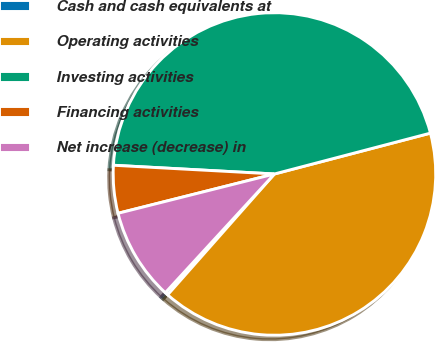<chart> <loc_0><loc_0><loc_500><loc_500><pie_chart><fcel>Cash and cash equivalents at<fcel>Operating activities<fcel>Investing activities<fcel>Financing activities<fcel>Net increase (decrease) in<nl><fcel>0.31%<fcel>40.59%<fcel>45.06%<fcel>4.78%<fcel>9.25%<nl></chart> 